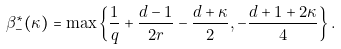<formula> <loc_0><loc_0><loc_500><loc_500>\beta ^ { * } _ { - } ( \kappa ) = \max \left \{ \frac { 1 } { q } + \frac { d - 1 } { 2 r } - \frac { d + \kappa } { 2 } , - \frac { d + 1 + 2 \kappa } { 4 } \right \} .</formula> 